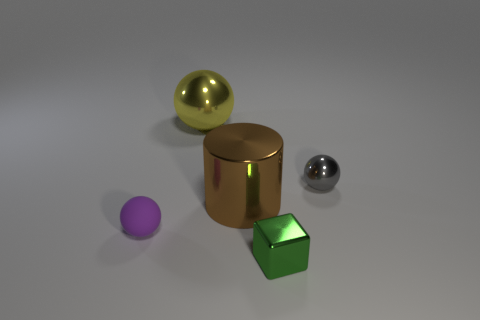Subtract all small metallic spheres. How many spheres are left? 2 Add 5 spheres. How many objects exist? 10 Subtract all spheres. How many objects are left? 2 Subtract all red spheres. Subtract all gray cylinders. How many spheres are left? 3 Subtract 0 cyan balls. How many objects are left? 5 Subtract all small gray metallic objects. Subtract all small purple rubber spheres. How many objects are left? 3 Add 5 small green metallic blocks. How many small green metallic blocks are left? 6 Add 3 big blue matte cylinders. How many big blue matte cylinders exist? 3 